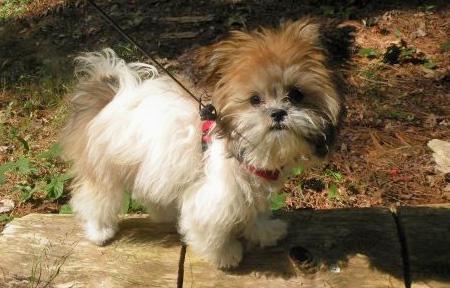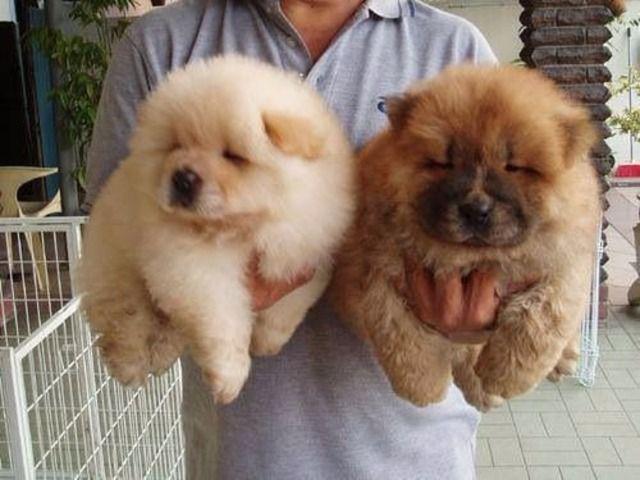The first image is the image on the left, the second image is the image on the right. Assess this claim about the two images: "Some type of small toy is next to a fluffy dog in one image.". Correct or not? Answer yes or no. No. 